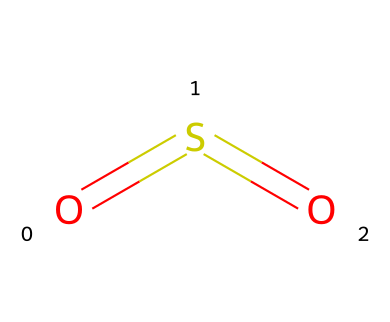What is the chemical name for this compound? The SMILES representation "O=S=O" indicates a sulfur atom bonded to two oxygen atoms with double bonds. The chemical name for this structure is sulfur dioxide.
Answer: sulfur dioxide How many oxygen atoms are present in this structure? The SMILES representation clearly shows two oxygen atoms connected to the sulfur atom, indicated by the two "O" letters.
Answer: 2 What type of bonds are found in sulfur dioxide? The structure "O=S=O" shows double bonds between sulfur and each oxygen atom, which are denoted by the equals signs.
Answer: double bonds What is the total number of atoms in sulfur dioxide? By analyzing the SMILES, we see one sulfur atom and two oxygen atoms, totaling three atoms in this compound.
Answer: 3 Is sulfur dioxide an acidic or basic compound? Sulfur dioxide, when dissolved in water, forms sulfurous acid. Therefore, it behaves as an acidic compound in aqueous solutions.
Answer: acidic What is the molecular geometry of sulfur dioxide? The structure suggests that sulfur dioxide has a bent or V-shape due to the two regions of electron density around the sulfur atom, leading to a bond angle of around 120 degrees.
Answer: bent What environmental issue is associated with sulfur dioxide? Sulfur dioxide is commonly linked to air pollution and is a significant contributor to acid rain, affecting both urban and rural environments.
Answer: acid rain 